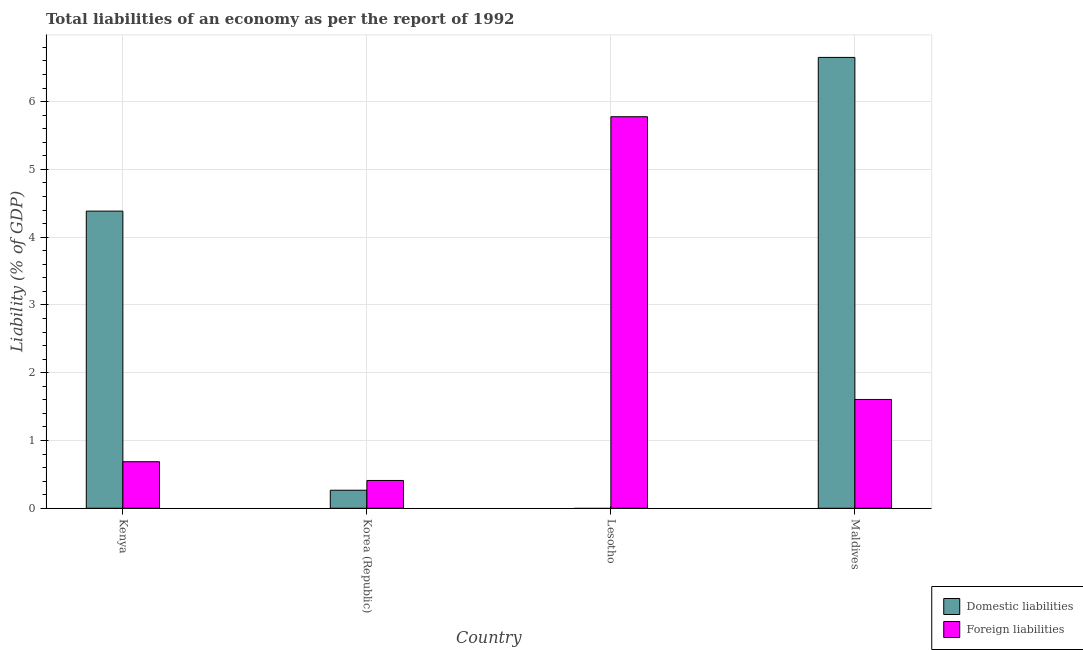Are the number of bars on each tick of the X-axis equal?
Provide a succinct answer. No. In how many cases, is the number of bars for a given country not equal to the number of legend labels?
Make the answer very short. 1. What is the incurrence of foreign liabilities in Kenya?
Offer a very short reply. 0.69. Across all countries, what is the maximum incurrence of foreign liabilities?
Make the answer very short. 5.78. Across all countries, what is the minimum incurrence of domestic liabilities?
Provide a short and direct response. 0. In which country was the incurrence of foreign liabilities maximum?
Your answer should be compact. Lesotho. What is the total incurrence of domestic liabilities in the graph?
Ensure brevity in your answer.  11.3. What is the difference between the incurrence of foreign liabilities in Lesotho and that in Maldives?
Offer a very short reply. 4.17. What is the difference between the incurrence of foreign liabilities in Maldives and the incurrence of domestic liabilities in Kenya?
Offer a very short reply. -2.78. What is the average incurrence of foreign liabilities per country?
Provide a short and direct response. 2.12. What is the difference between the incurrence of domestic liabilities and incurrence of foreign liabilities in Korea (Republic)?
Your answer should be very brief. -0.14. In how many countries, is the incurrence of domestic liabilities greater than 3.4 %?
Make the answer very short. 2. What is the ratio of the incurrence of foreign liabilities in Lesotho to that in Maldives?
Offer a terse response. 3.6. What is the difference between the highest and the second highest incurrence of foreign liabilities?
Ensure brevity in your answer.  4.17. What is the difference between the highest and the lowest incurrence of foreign liabilities?
Offer a terse response. 5.37. In how many countries, is the incurrence of foreign liabilities greater than the average incurrence of foreign liabilities taken over all countries?
Your answer should be compact. 1. How many bars are there?
Give a very brief answer. 7. How many countries are there in the graph?
Your answer should be very brief. 4. Are the values on the major ticks of Y-axis written in scientific E-notation?
Offer a very short reply. No. Does the graph contain grids?
Offer a very short reply. Yes. Where does the legend appear in the graph?
Ensure brevity in your answer.  Bottom right. What is the title of the graph?
Your response must be concise. Total liabilities of an economy as per the report of 1992. Does "From human activities" appear as one of the legend labels in the graph?
Provide a short and direct response. No. What is the label or title of the X-axis?
Provide a short and direct response. Country. What is the label or title of the Y-axis?
Make the answer very short. Liability (% of GDP). What is the Liability (% of GDP) of Domestic liabilities in Kenya?
Offer a very short reply. 4.38. What is the Liability (% of GDP) of Foreign liabilities in Kenya?
Your answer should be very brief. 0.69. What is the Liability (% of GDP) of Domestic liabilities in Korea (Republic)?
Your answer should be compact. 0.27. What is the Liability (% of GDP) of Foreign liabilities in Korea (Republic)?
Provide a succinct answer. 0.41. What is the Liability (% of GDP) of Foreign liabilities in Lesotho?
Keep it short and to the point. 5.78. What is the Liability (% of GDP) of Domestic liabilities in Maldives?
Your response must be concise. 6.65. What is the Liability (% of GDP) of Foreign liabilities in Maldives?
Provide a short and direct response. 1.61. Across all countries, what is the maximum Liability (% of GDP) of Domestic liabilities?
Keep it short and to the point. 6.65. Across all countries, what is the maximum Liability (% of GDP) of Foreign liabilities?
Offer a terse response. 5.78. Across all countries, what is the minimum Liability (% of GDP) in Domestic liabilities?
Your answer should be compact. 0. Across all countries, what is the minimum Liability (% of GDP) in Foreign liabilities?
Give a very brief answer. 0.41. What is the total Liability (% of GDP) of Domestic liabilities in the graph?
Give a very brief answer. 11.3. What is the total Liability (% of GDP) in Foreign liabilities in the graph?
Offer a terse response. 8.48. What is the difference between the Liability (% of GDP) in Domestic liabilities in Kenya and that in Korea (Republic)?
Offer a very short reply. 4.12. What is the difference between the Liability (% of GDP) in Foreign liabilities in Kenya and that in Korea (Republic)?
Provide a short and direct response. 0.28. What is the difference between the Liability (% of GDP) of Foreign liabilities in Kenya and that in Lesotho?
Your response must be concise. -5.09. What is the difference between the Liability (% of GDP) of Domestic liabilities in Kenya and that in Maldives?
Keep it short and to the point. -2.27. What is the difference between the Liability (% of GDP) of Foreign liabilities in Kenya and that in Maldives?
Offer a very short reply. -0.92. What is the difference between the Liability (% of GDP) in Foreign liabilities in Korea (Republic) and that in Lesotho?
Your answer should be compact. -5.37. What is the difference between the Liability (% of GDP) in Domestic liabilities in Korea (Republic) and that in Maldives?
Provide a short and direct response. -6.39. What is the difference between the Liability (% of GDP) in Foreign liabilities in Korea (Republic) and that in Maldives?
Provide a succinct answer. -1.2. What is the difference between the Liability (% of GDP) of Foreign liabilities in Lesotho and that in Maldives?
Keep it short and to the point. 4.17. What is the difference between the Liability (% of GDP) in Domestic liabilities in Kenya and the Liability (% of GDP) in Foreign liabilities in Korea (Republic)?
Your answer should be very brief. 3.97. What is the difference between the Liability (% of GDP) of Domestic liabilities in Kenya and the Liability (% of GDP) of Foreign liabilities in Lesotho?
Your response must be concise. -1.39. What is the difference between the Liability (% of GDP) of Domestic liabilities in Kenya and the Liability (% of GDP) of Foreign liabilities in Maldives?
Offer a terse response. 2.78. What is the difference between the Liability (% of GDP) of Domestic liabilities in Korea (Republic) and the Liability (% of GDP) of Foreign liabilities in Lesotho?
Offer a terse response. -5.51. What is the difference between the Liability (% of GDP) in Domestic liabilities in Korea (Republic) and the Liability (% of GDP) in Foreign liabilities in Maldives?
Keep it short and to the point. -1.34. What is the average Liability (% of GDP) in Domestic liabilities per country?
Provide a short and direct response. 2.83. What is the average Liability (% of GDP) of Foreign liabilities per country?
Your answer should be compact. 2.12. What is the difference between the Liability (% of GDP) of Domestic liabilities and Liability (% of GDP) of Foreign liabilities in Kenya?
Give a very brief answer. 3.7. What is the difference between the Liability (% of GDP) in Domestic liabilities and Liability (% of GDP) in Foreign liabilities in Korea (Republic)?
Keep it short and to the point. -0.14. What is the difference between the Liability (% of GDP) of Domestic liabilities and Liability (% of GDP) of Foreign liabilities in Maldives?
Your response must be concise. 5.05. What is the ratio of the Liability (% of GDP) of Domestic liabilities in Kenya to that in Korea (Republic)?
Provide a short and direct response. 16.47. What is the ratio of the Liability (% of GDP) of Foreign liabilities in Kenya to that in Korea (Republic)?
Your answer should be very brief. 1.67. What is the ratio of the Liability (% of GDP) in Foreign liabilities in Kenya to that in Lesotho?
Your answer should be compact. 0.12. What is the ratio of the Liability (% of GDP) in Domestic liabilities in Kenya to that in Maldives?
Your response must be concise. 0.66. What is the ratio of the Liability (% of GDP) of Foreign liabilities in Kenya to that in Maldives?
Give a very brief answer. 0.43. What is the ratio of the Liability (% of GDP) of Foreign liabilities in Korea (Republic) to that in Lesotho?
Keep it short and to the point. 0.07. What is the ratio of the Liability (% of GDP) of Domestic liabilities in Korea (Republic) to that in Maldives?
Provide a short and direct response. 0.04. What is the ratio of the Liability (% of GDP) of Foreign liabilities in Korea (Republic) to that in Maldives?
Offer a terse response. 0.26. What is the ratio of the Liability (% of GDP) of Foreign liabilities in Lesotho to that in Maldives?
Give a very brief answer. 3.6. What is the difference between the highest and the second highest Liability (% of GDP) of Domestic liabilities?
Give a very brief answer. 2.27. What is the difference between the highest and the second highest Liability (% of GDP) in Foreign liabilities?
Offer a terse response. 4.17. What is the difference between the highest and the lowest Liability (% of GDP) of Domestic liabilities?
Offer a terse response. 6.65. What is the difference between the highest and the lowest Liability (% of GDP) in Foreign liabilities?
Offer a very short reply. 5.37. 